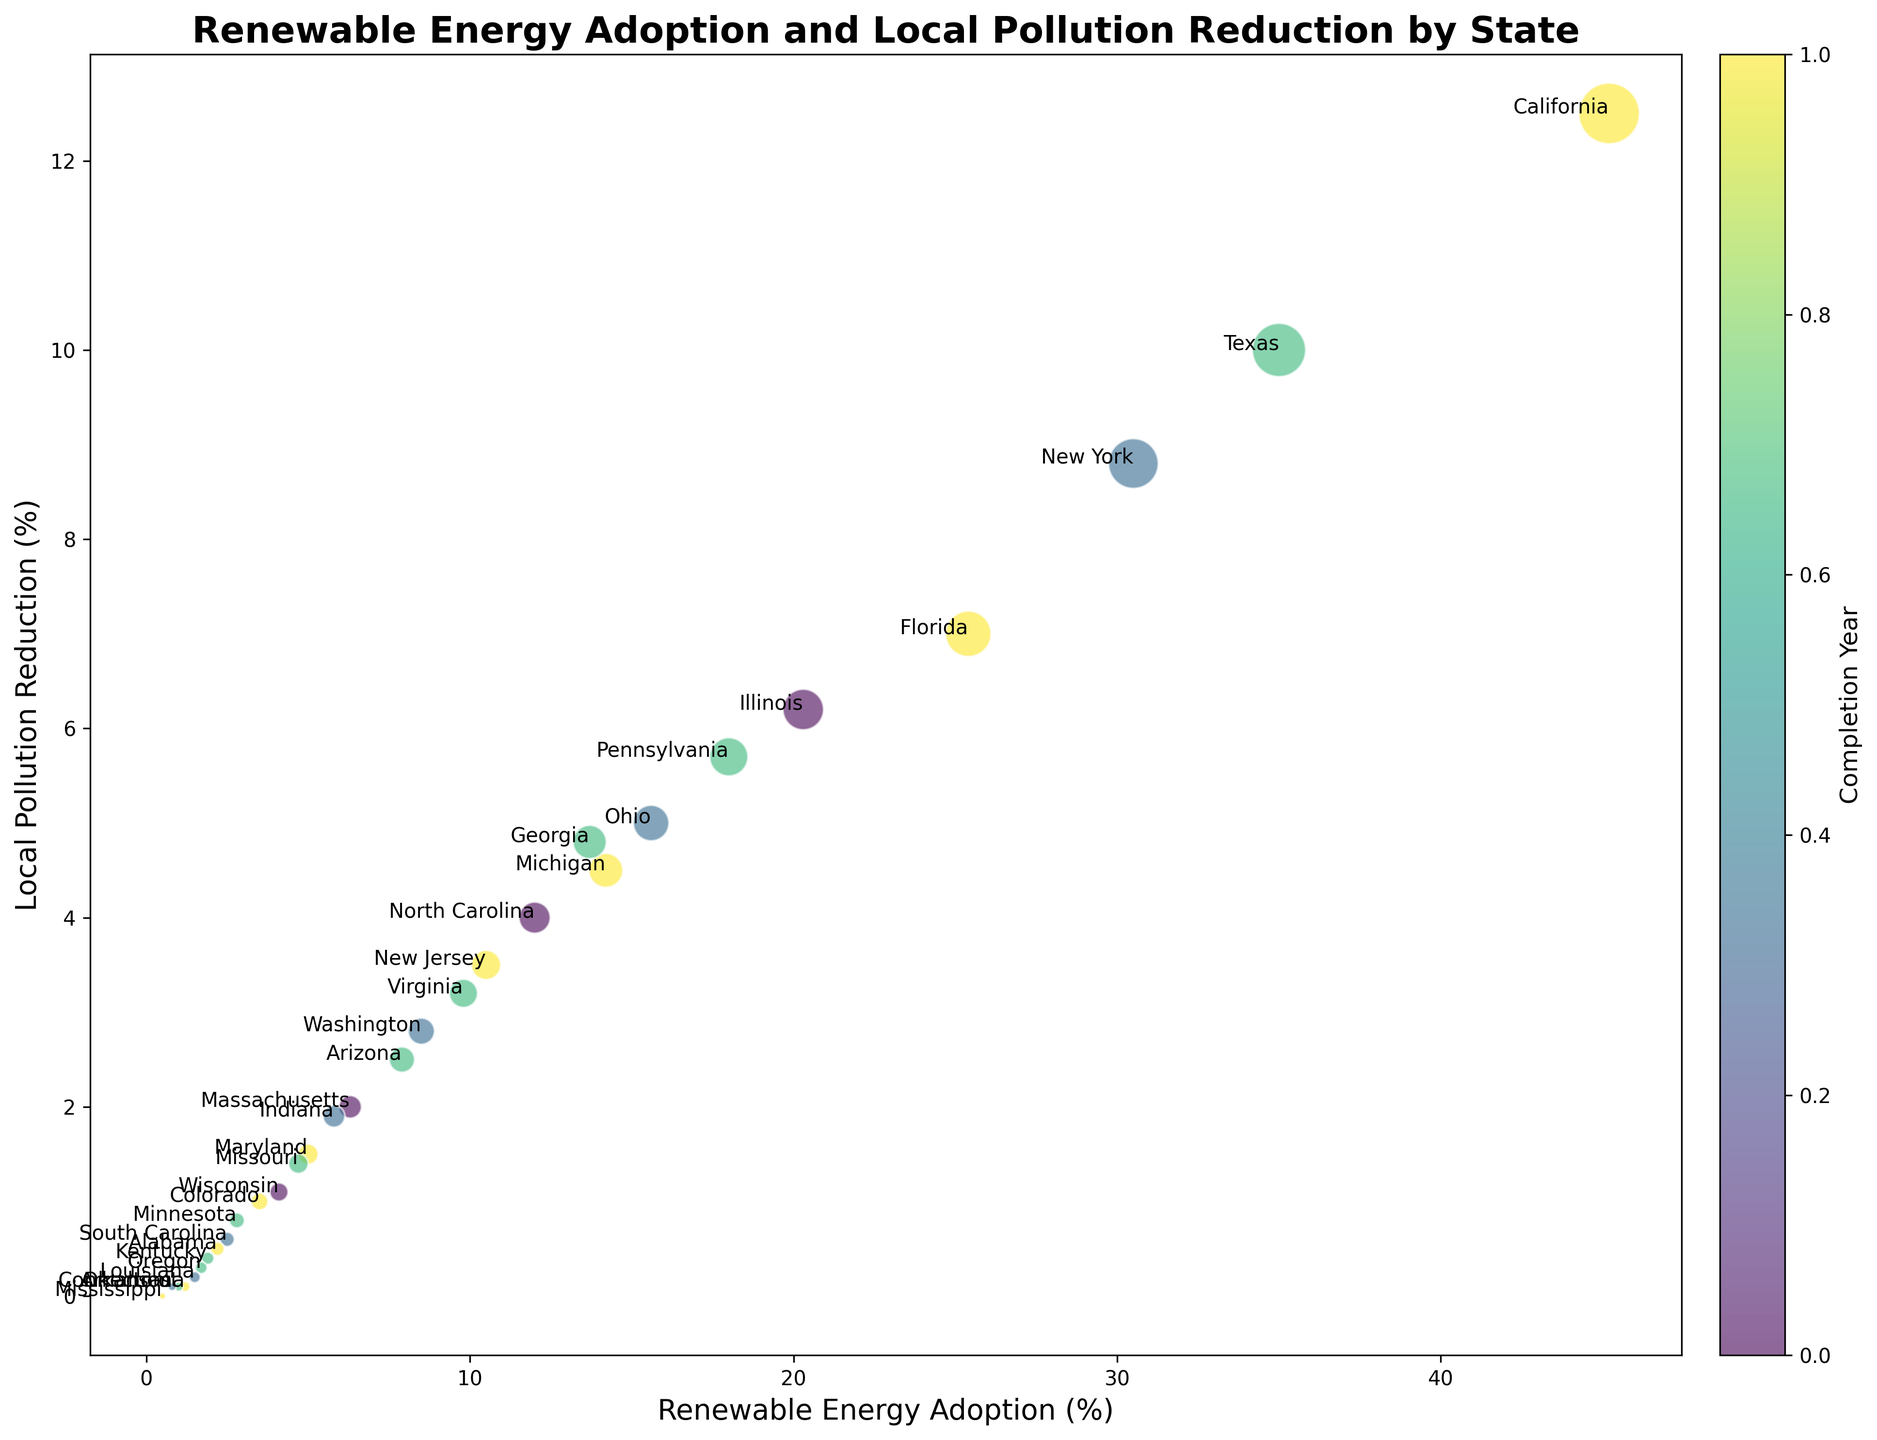Which state has the highest renewable energy adoption percentage? By looking at the chart, identify the state with the largest bubble along the x-axis, which represents renewable energy adoption percentage. California has the highest renewable energy adoption percentage.
Answer: California Which state has the lowest local pollution reduction percentage? Locate the state with the smallest bubble along the y-axis, which represents local pollution reduction percentage. Mississippi has the lowest local pollution reduction percentage.
Answer: Mississippi What state achieved a 10% adoption of renewable energy sources in 2020? Look for the bubble situated around the 10% mark on the x-axis and for the color on the bubble that corresponds to the completion year 2020 (from the color bar). New Jersey achieved a 10% adoption in 2021.
Answer: New Jersey Compare the local pollution reduction percentages of California and Texas. Which state has a higher reduction? Identify the bubbles associated with California and Texas and compare their positions along the y-axis. California's bubble is higher along the y-axis, indicating a higher pollution reduction percentage.
Answer: California How is the size of the bubbles related to renewable energy adoption percentages? Assess the visual relationship between the bubbles' sizes and their positions along the x-axis. Larger bubbles correspond to higher adoption percentages.
Answer: Larger bubbles represent higher adoption percentages Which state has a renewable energy adoption percentage closest to 15%? Find the bubble that is positioned near the 15% mark on the x-axis. Ohio has a renewable energy adoption percentage closest to 15%.
Answer: Ohio Which state that completed its renewable energy adoption in 2019, achieved the highest local pollution reduction percentage? Among the bubbles with the color for the completion year 2019 (refer to the color bar), identify the one positioned highest along the y-axis. New York is the state with the highest local pollution reduction among those completed in 2019.
Answer: New York What is the total local pollution reduction percentage for states that have a renewable energy adoption percentage above 20%? Find the bubbles with x-axis values above 20%. These states are California, Texas, New York, Florida, and Illinois. Sum their y-axis values (pollution reduction percentages): 12.5 + 10.0 + 8.8 + 7.0 + 6.2 = 44.5%.
Answer: 44.5% Which state shows a renewable energy adoption percentage of about 10% and what is its local pollution reduction percentage? Identify the bubble positioned around the 10% mark on the x-axis and check its position on the y-axis for its pollution reduction percentage. New Jersey shows an adoption percentage of about 10% with a local pollution reduction of 3.5%.
Answer: New Jersey has a 3.5% reduction 